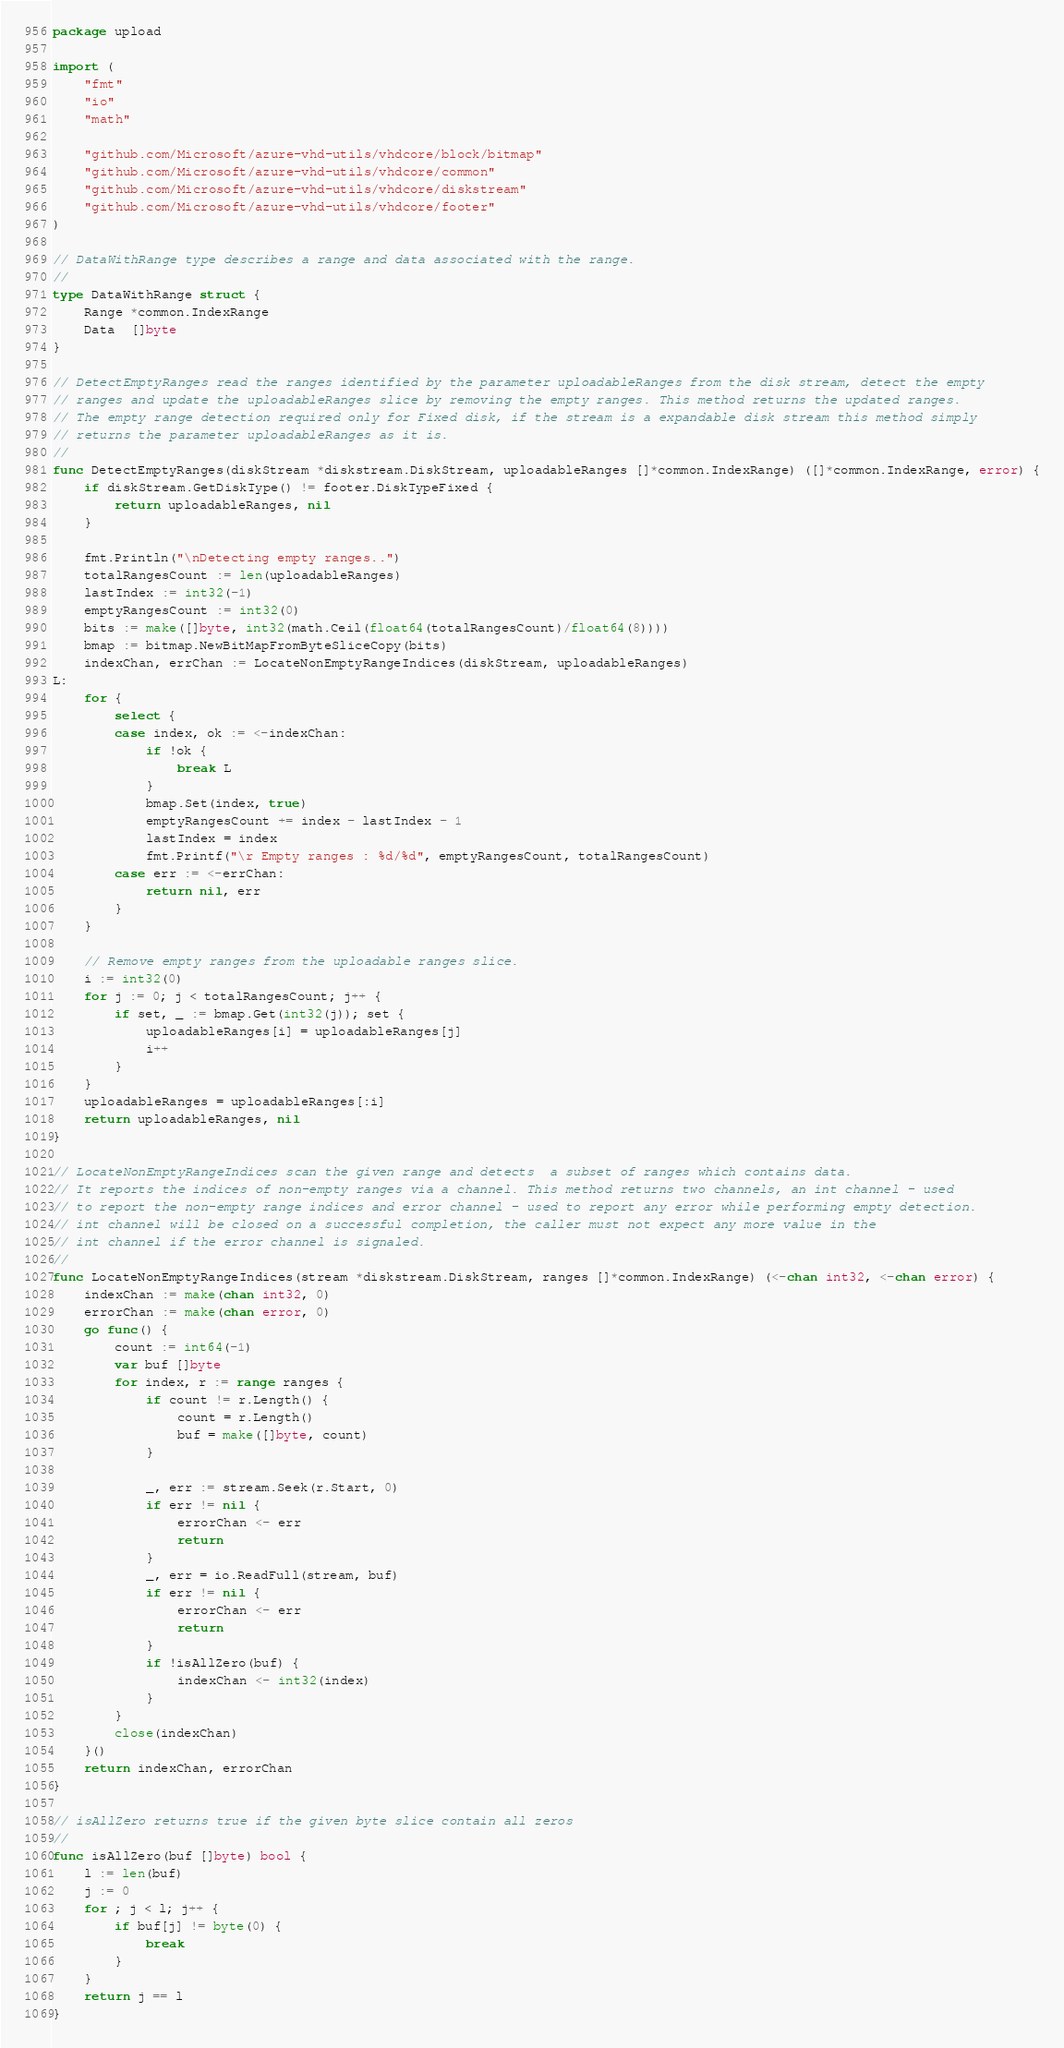<code> <loc_0><loc_0><loc_500><loc_500><_Go_>package upload

import (
	"fmt"
	"io"
	"math"

	"github.com/Microsoft/azure-vhd-utils/vhdcore/block/bitmap"
	"github.com/Microsoft/azure-vhd-utils/vhdcore/common"
	"github.com/Microsoft/azure-vhd-utils/vhdcore/diskstream"
	"github.com/Microsoft/azure-vhd-utils/vhdcore/footer"
)

// DataWithRange type describes a range and data associated with the range.
//
type DataWithRange struct {
	Range *common.IndexRange
	Data  []byte
}

// DetectEmptyRanges read the ranges identified by the parameter uploadableRanges from the disk stream, detect the empty
// ranges and update the uploadableRanges slice by removing the empty ranges. This method returns the updated ranges.
// The empty range detection required only for Fixed disk, if the stream is a expandable disk stream this method simply
// returns the parameter uploadableRanges as it is.
//
func DetectEmptyRanges(diskStream *diskstream.DiskStream, uploadableRanges []*common.IndexRange) ([]*common.IndexRange, error) {
	if diskStream.GetDiskType() != footer.DiskTypeFixed {
		return uploadableRanges, nil
	}

	fmt.Println("\nDetecting empty ranges..")
	totalRangesCount := len(uploadableRanges)
	lastIndex := int32(-1)
	emptyRangesCount := int32(0)
	bits := make([]byte, int32(math.Ceil(float64(totalRangesCount)/float64(8))))
	bmap := bitmap.NewBitMapFromByteSliceCopy(bits)
	indexChan, errChan := LocateNonEmptyRangeIndices(diskStream, uploadableRanges)
L:
	for {
		select {
		case index, ok := <-indexChan:
			if !ok {
				break L
			}
			bmap.Set(index, true)
			emptyRangesCount += index - lastIndex - 1
			lastIndex = index
			fmt.Printf("\r Empty ranges : %d/%d", emptyRangesCount, totalRangesCount)
		case err := <-errChan:
			return nil, err
		}
	}

	// Remove empty ranges from the uploadable ranges slice.
	i := int32(0)
	for j := 0; j < totalRangesCount; j++ {
		if set, _ := bmap.Get(int32(j)); set {
			uploadableRanges[i] = uploadableRanges[j]
			i++
		}
	}
	uploadableRanges = uploadableRanges[:i]
	return uploadableRanges, nil
}

// LocateNonEmptyRangeIndices scan the given range and detects  a subset of ranges which contains data.
// It reports the indices of non-empty ranges via a channel. This method returns two channels, an int channel - used
// to report the non-empty range indices and error channel - used to report any error while performing empty detection.
// int channel will be closed on a successful completion, the caller must not expect any more value in the
// int channel if the error channel is signaled.
//
func LocateNonEmptyRangeIndices(stream *diskstream.DiskStream, ranges []*common.IndexRange) (<-chan int32, <-chan error) {
	indexChan := make(chan int32, 0)
	errorChan := make(chan error, 0)
	go func() {
		count := int64(-1)
		var buf []byte
		for index, r := range ranges {
			if count != r.Length() {
				count = r.Length()
				buf = make([]byte, count)
			}

			_, err := stream.Seek(r.Start, 0)
			if err != nil {
				errorChan <- err
				return
			}
			_, err = io.ReadFull(stream, buf)
			if err != nil {
				errorChan <- err
				return
			}
			if !isAllZero(buf) {
				indexChan <- int32(index)
			}
		}
		close(indexChan)
	}()
	return indexChan, errorChan
}

// isAllZero returns true if the given byte slice contain all zeros
//
func isAllZero(buf []byte) bool {
	l := len(buf)
	j := 0
	for ; j < l; j++ {
		if buf[j] != byte(0) {
			break
		}
	}
	return j == l
}
</code> 